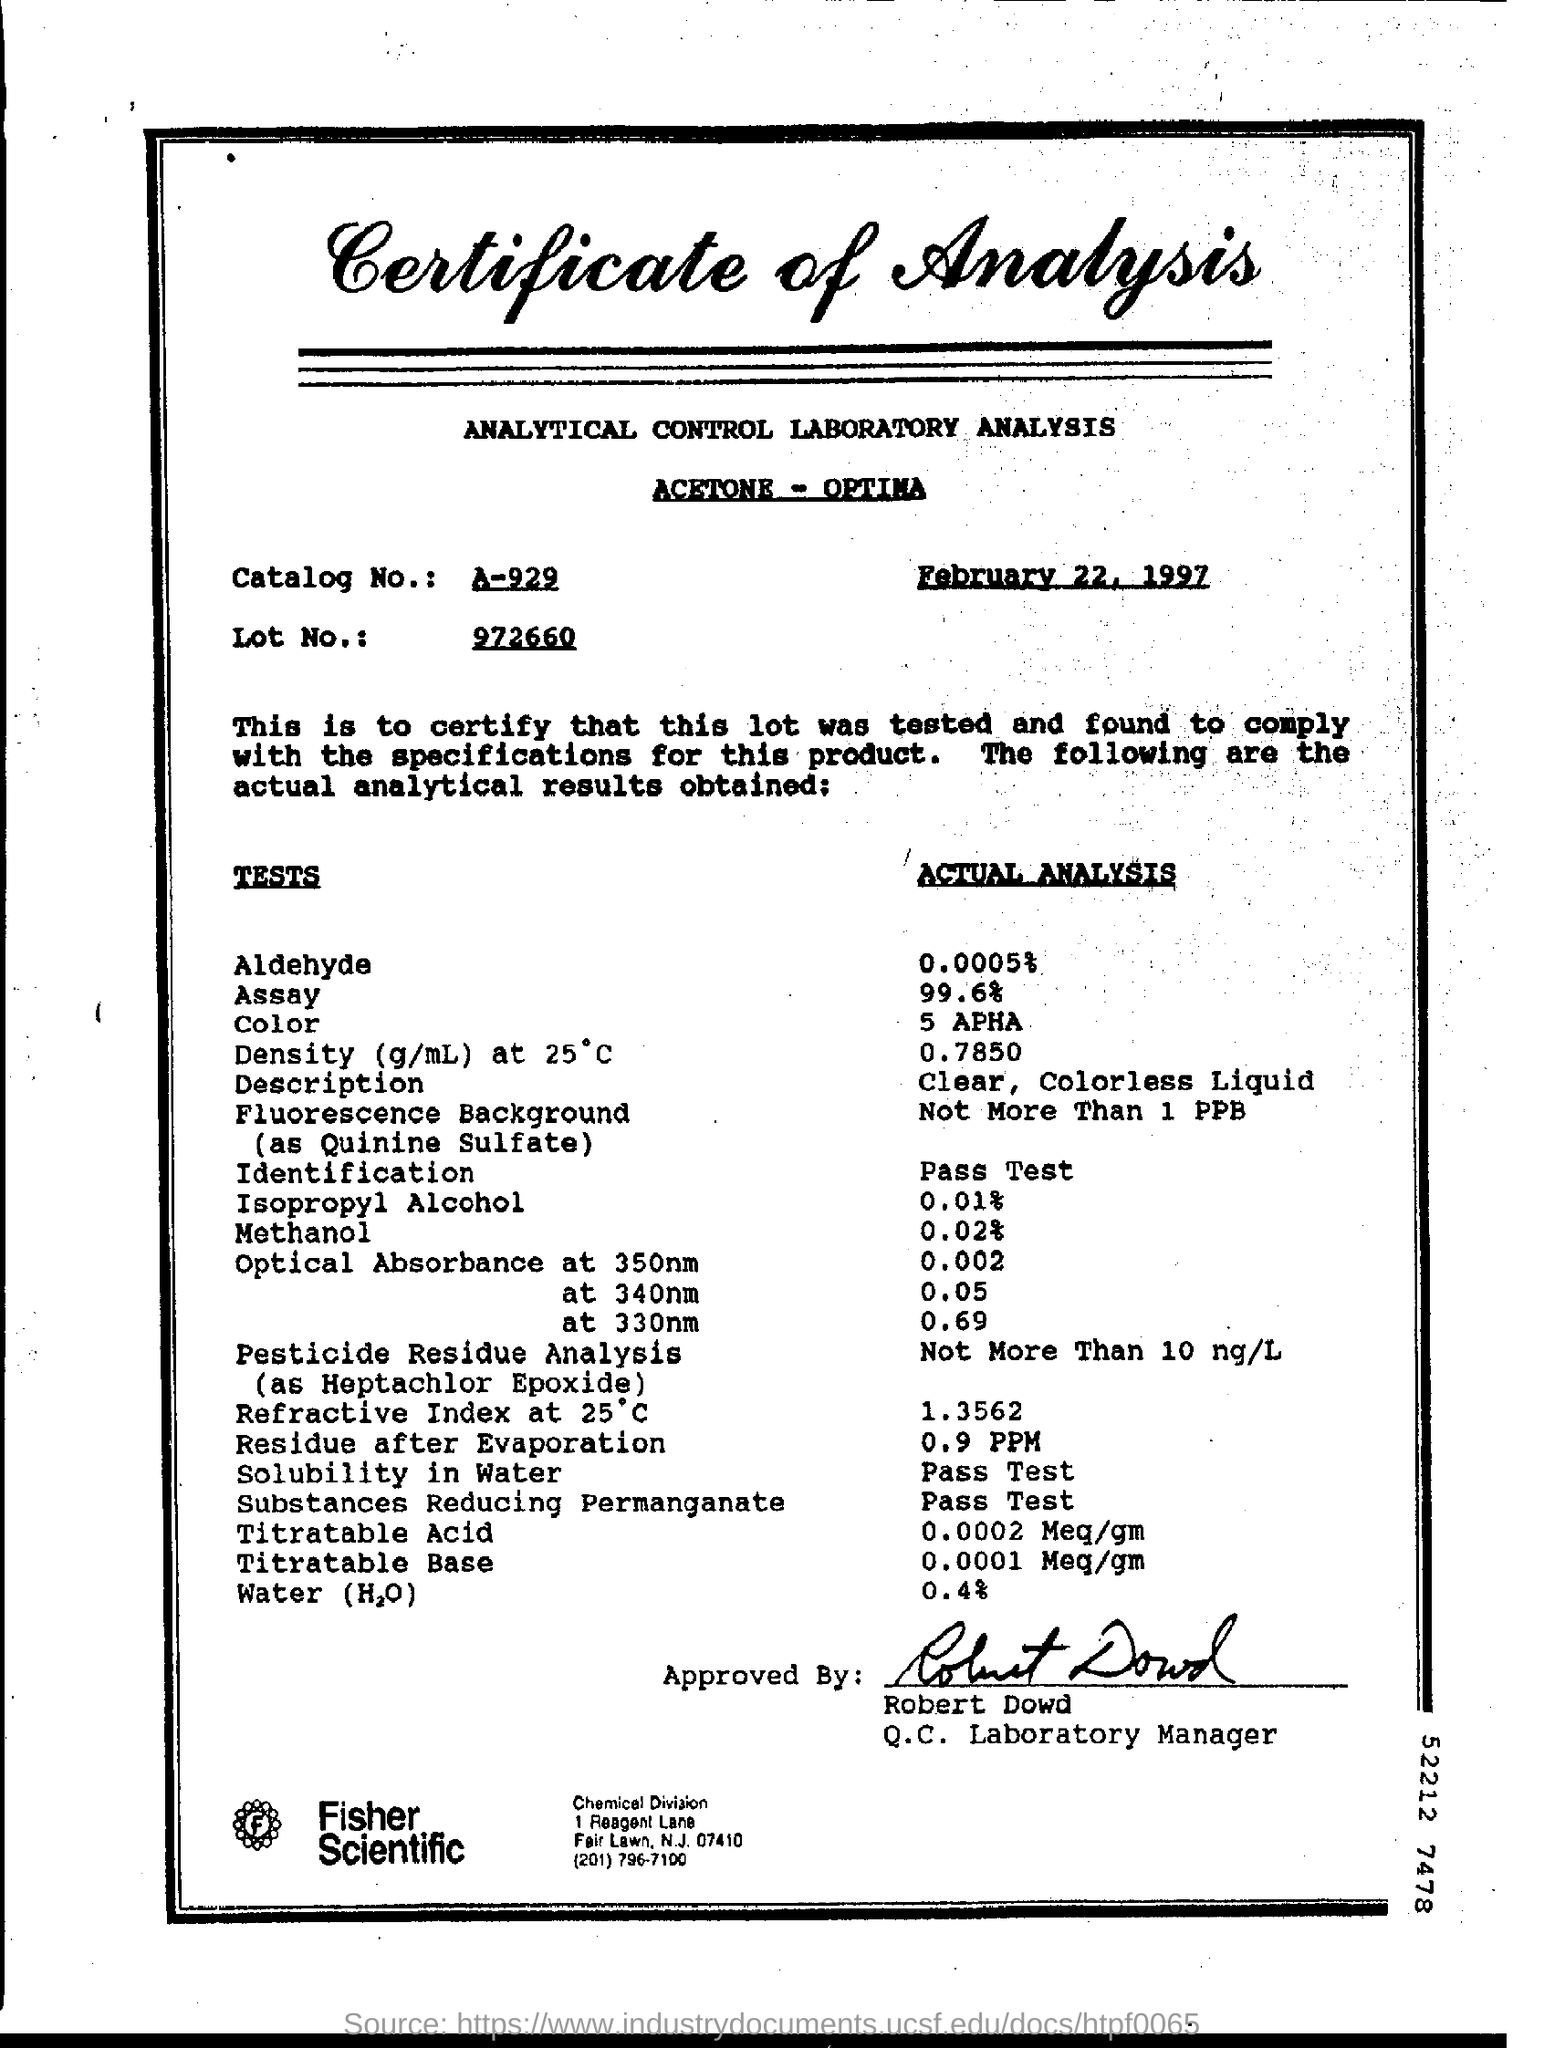When is the certificate dated?
Provide a short and direct response. February 22, 1997. What is the Catalog No.?
Offer a terse response. A-929. What is the Lot no.?
Provide a succinct answer. 972660. What is the percentage of Aldehyde in actual analysis?
Provide a succinct answer. 0.0005 %. What was the amount of Residue after Evaporation?
Give a very brief answer. 0.9 PPM. 